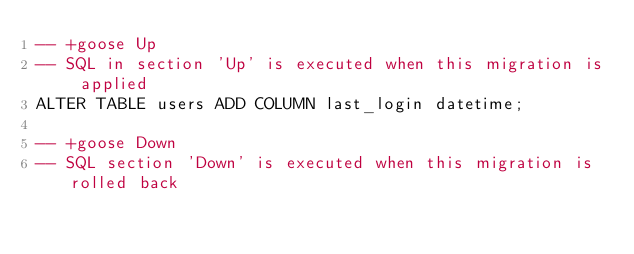<code> <loc_0><loc_0><loc_500><loc_500><_SQL_>-- +goose Up
-- SQL in section 'Up' is executed when this migration is applied
ALTER TABLE users ADD COLUMN last_login datetime;

-- +goose Down
-- SQL section 'Down' is executed when this migration is rolled back
</code> 